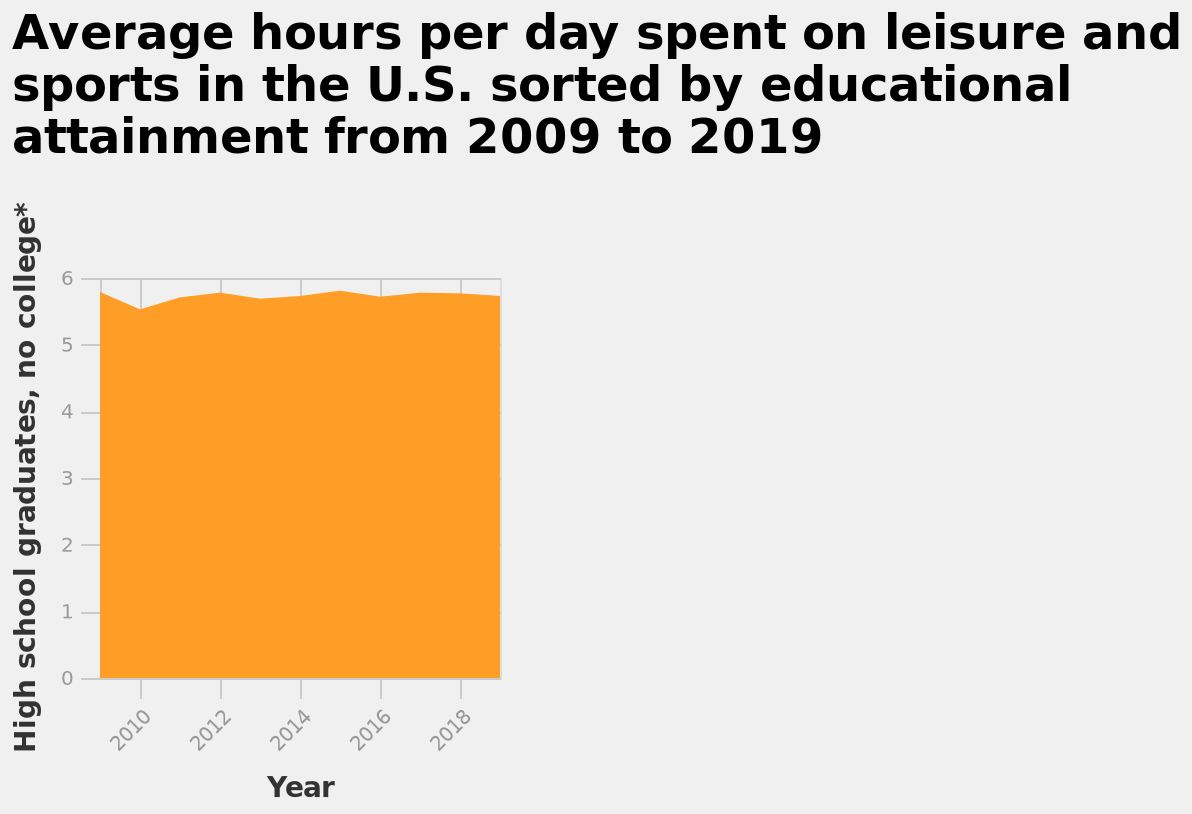<image>
Offer a thorough analysis of the image. Over the period of time from 2010 to 2018 the average hours high school graduates spend on sports and leisure has stayed steady. Describe the following image in detail Average hours per day spent on leisure and sports in the U.S. sorted by educational attainment from 2009 to 2019 is a area diagram. The y-axis plots High school graduates, no college* on linear scale with a minimum of 0 and a maximum of 6 while the x-axis shows Year along linear scale from 2010 to 2018. What is the range of the y-axis in the area diagram?  The y-axis has a range from 0 to 6 on a linear scale. 